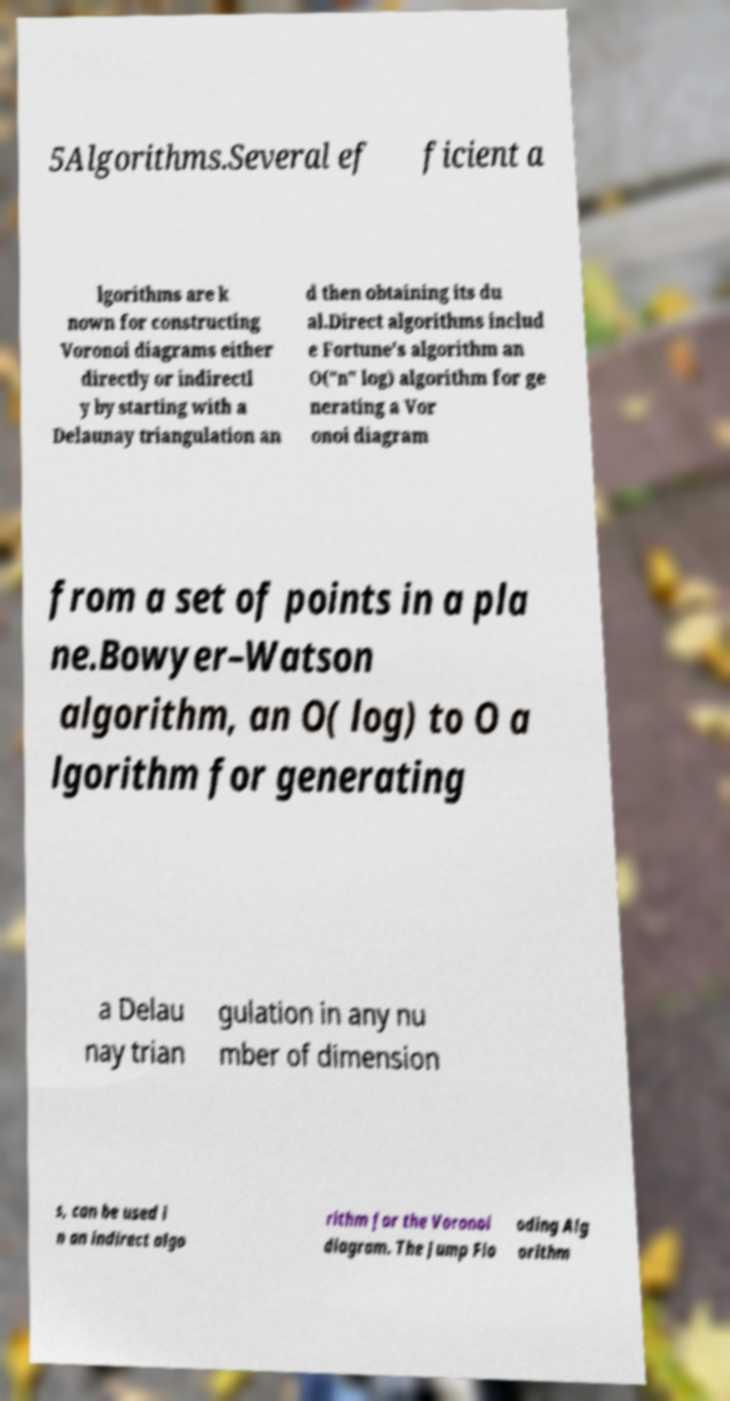Can you read and provide the text displayed in the image?This photo seems to have some interesting text. Can you extract and type it out for me? 5Algorithms.Several ef ficient a lgorithms are k nown for constructing Voronoi diagrams either directly or indirectl y by starting with a Delaunay triangulation an d then obtaining its du al.Direct algorithms includ e Fortune's algorithm an O("n" log) algorithm for ge nerating a Vor onoi diagram from a set of points in a pla ne.Bowyer–Watson algorithm, an O( log) to O a lgorithm for generating a Delau nay trian gulation in any nu mber of dimension s, can be used i n an indirect algo rithm for the Voronoi diagram. The Jump Flo oding Alg orithm 